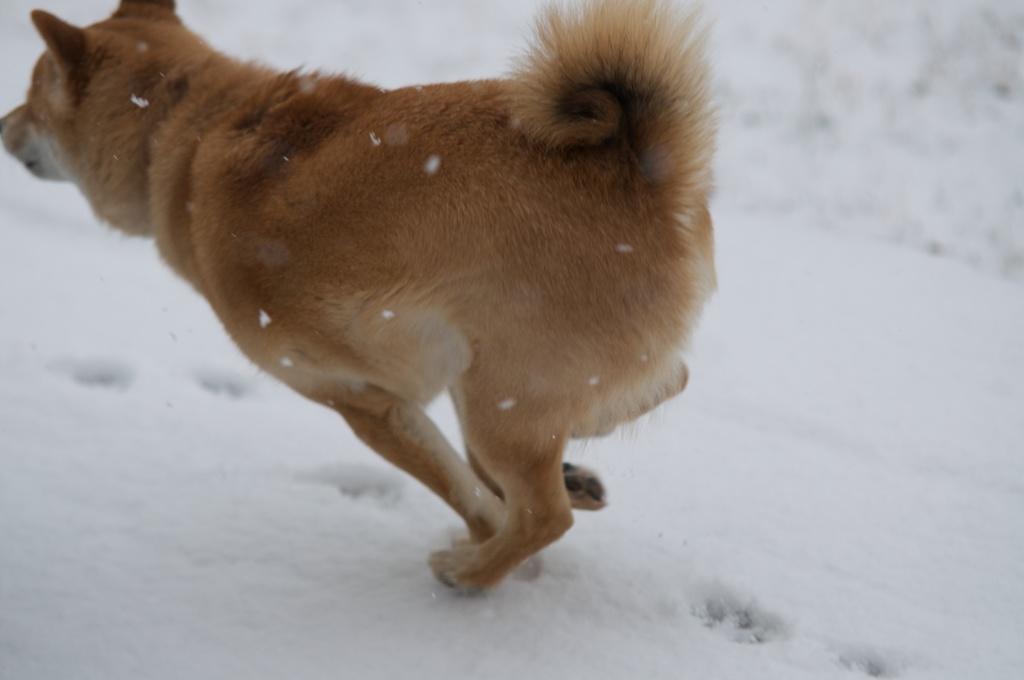Can you describe this image briefly? In the image a dog is running on snow. 